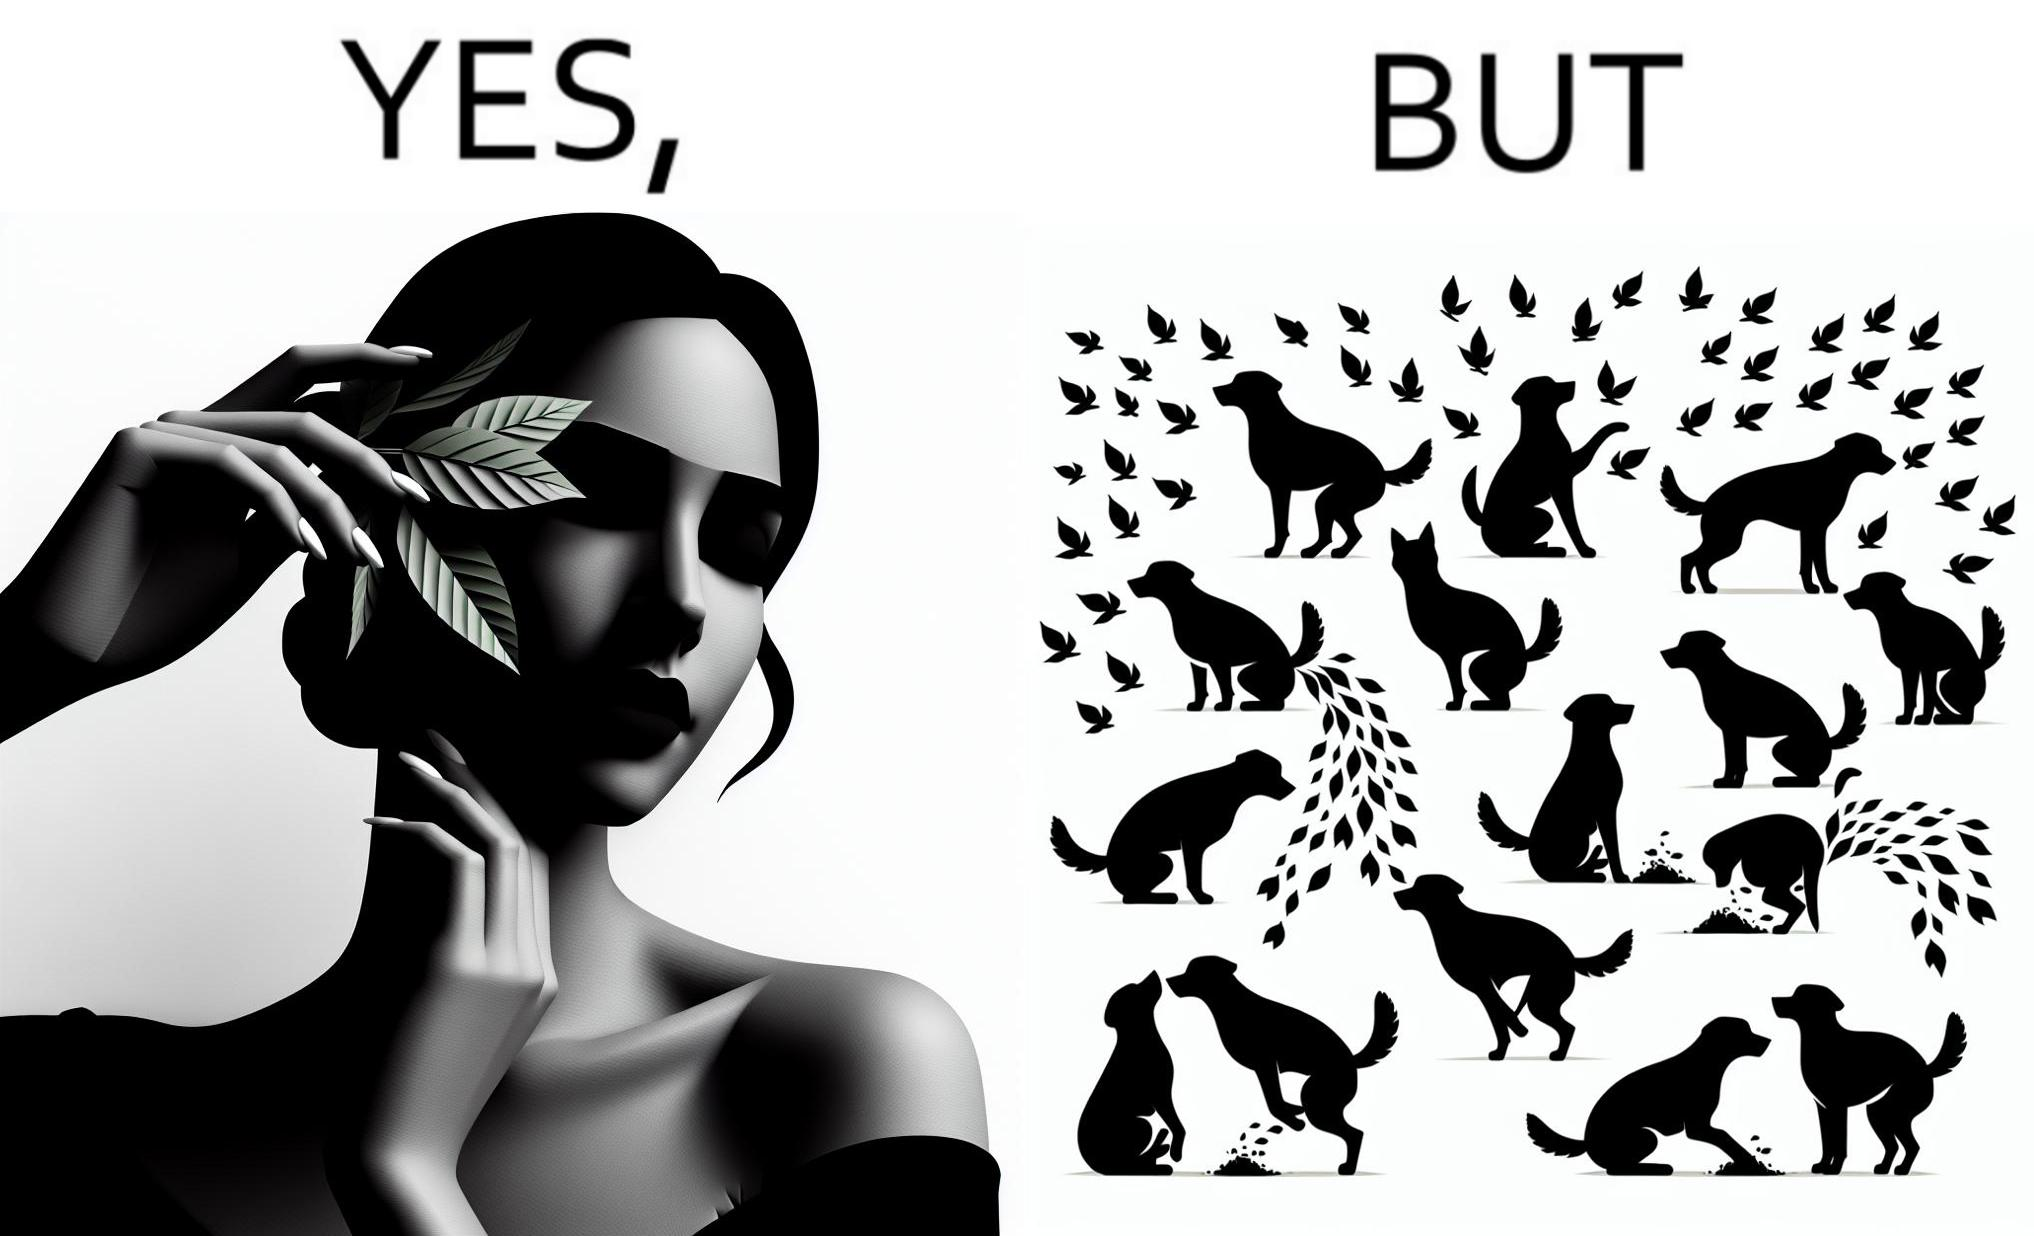What makes this image funny or satirical? The images are funny since it show a woman holding a leaf over half of her face for a good photo but unknown to her is thale fact the same leaf might have been defecated or urinated upon by dogs and other wild animals 